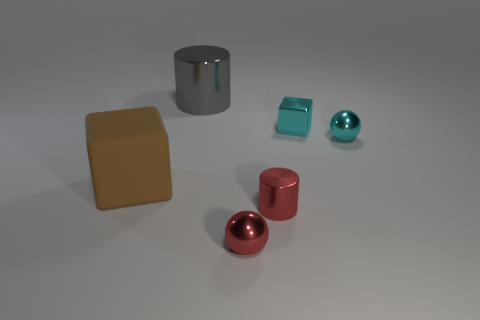What color is the small sphere that is in front of the cube that is to the left of the cylinder that is behind the big brown object?
Keep it short and to the point. Red. There is a shiny cylinder that is behind the big brown object; what is its size?
Your response must be concise. Large. What number of tiny objects are either brown cylinders or brown things?
Your answer should be compact. 0. There is a metallic thing that is to the left of the red cylinder and in front of the gray shiny cylinder; what is its color?
Offer a terse response. Red. Is there another large gray shiny object that has the same shape as the large metal object?
Ensure brevity in your answer.  No. What is the material of the tiny cyan sphere?
Provide a short and direct response. Metal. There is a big brown cube; are there any small red cylinders behind it?
Provide a short and direct response. No. Is the shape of the gray metallic object the same as the large brown thing?
Ensure brevity in your answer.  No. What number of other objects are there of the same size as the rubber block?
Give a very brief answer. 1. How many objects are either cylinders that are to the right of the big cylinder or small cyan metallic spheres?
Your answer should be compact. 2. 